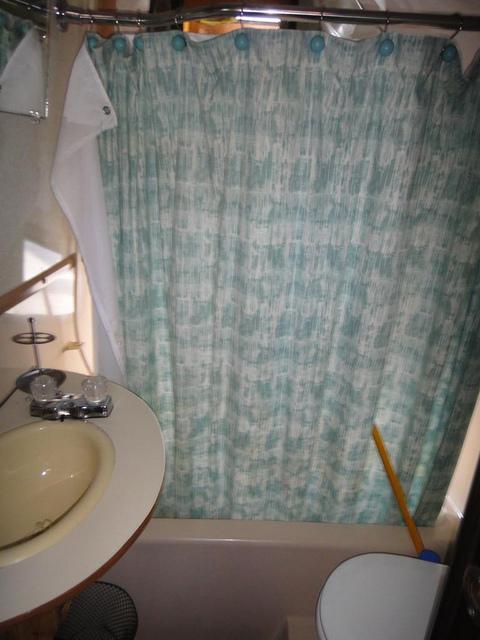How many sinks are in the picture?
Give a very brief answer. 1. 